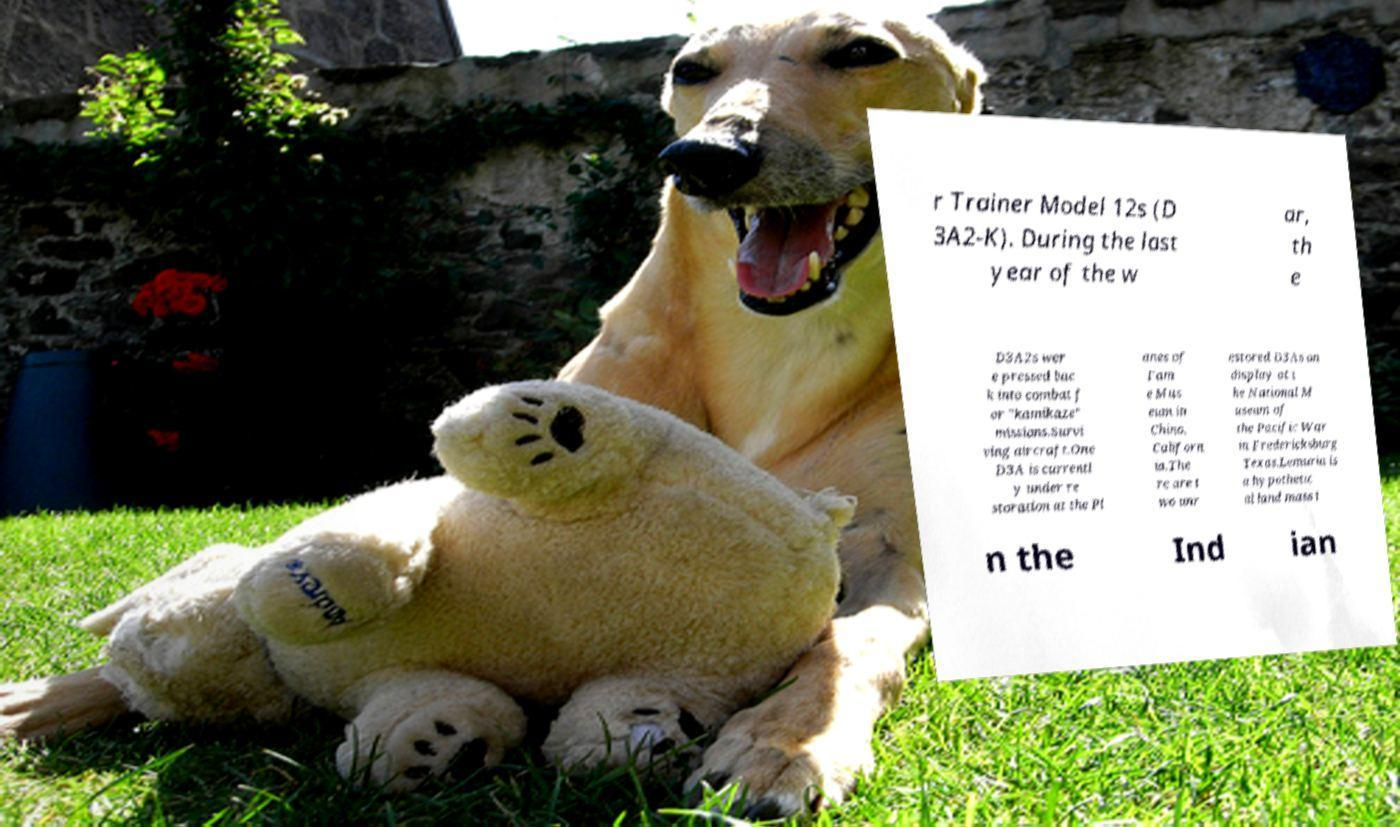I need the written content from this picture converted into text. Can you do that? r Trainer Model 12s (D 3A2-K). During the last year of the w ar, th e D3A2s wer e pressed bac k into combat f or "kamikaze" missions.Survi ving aircraft.One D3A is currentl y under re storation at the Pl anes of Fam e Mus eum in Chino, Californ ia.The re are t wo unr estored D3As on display at t he National M useum of the Pacific War in Fredericksburg Texas.Lemuria is a hypothetic al land mass i n the Ind ian 